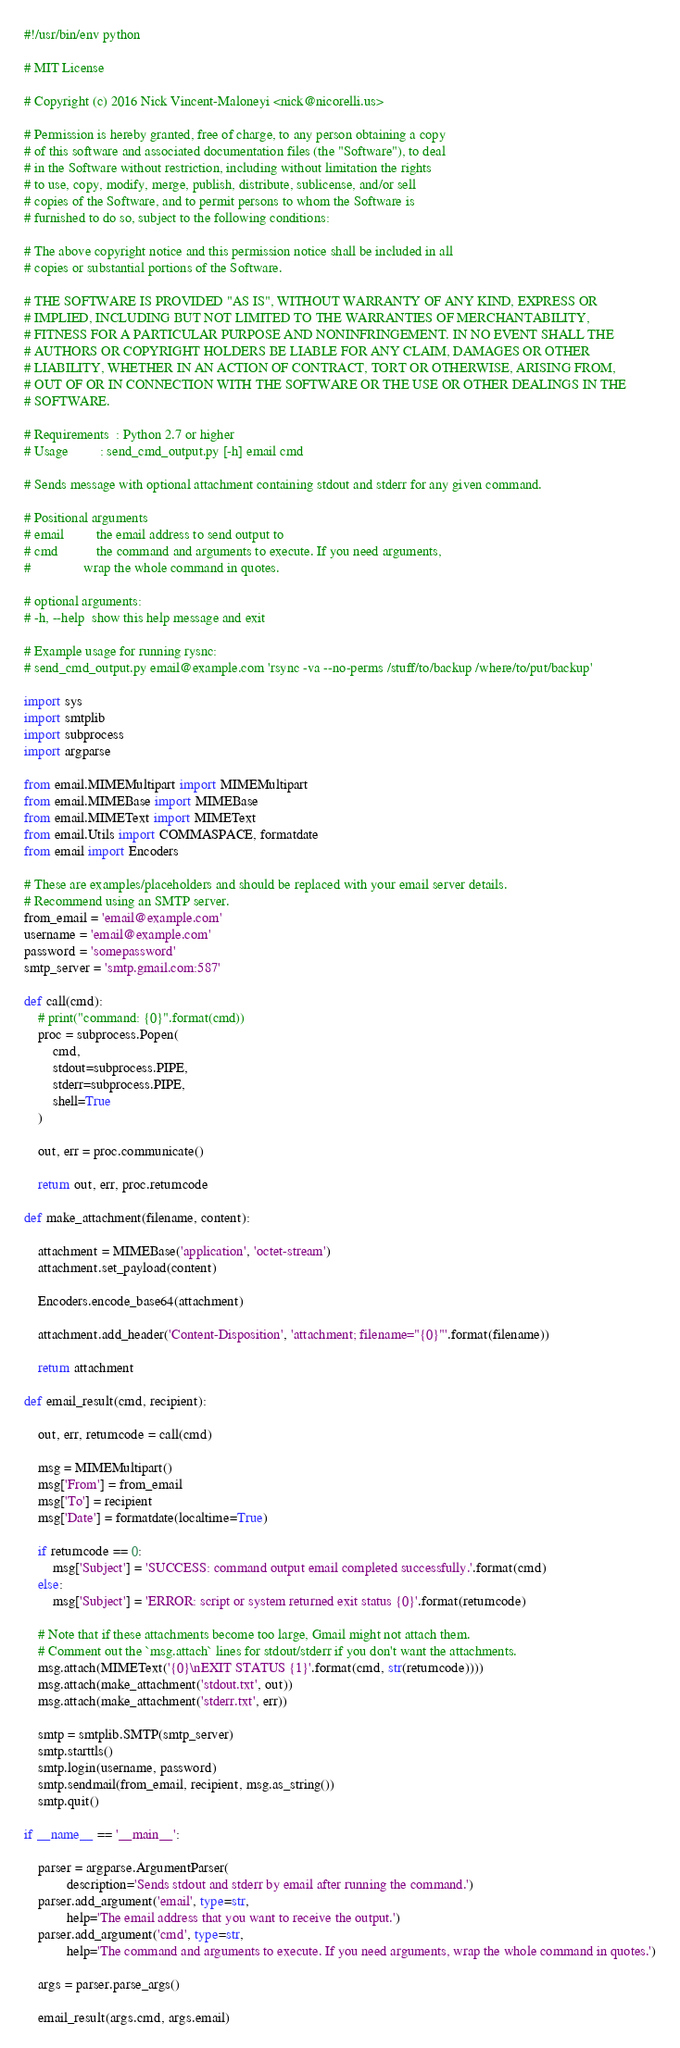<code> <loc_0><loc_0><loc_500><loc_500><_Python_>#!/usr/bin/env python

# MIT License

# Copyright (c) 2016 Nick Vincent-Maloneyi <nick@nicorelli.us>

# Permission is hereby granted, free of charge, to any person obtaining a copy
# of this software and associated documentation files (the "Software"), to deal
# in the Software without restriction, including without limitation the rights
# to use, copy, modify, merge, publish, distribute, sublicense, and/or sell
# copies of the Software, and to permit persons to whom the Software is
# furnished to do so, subject to the following conditions:
 
# The above copyright notice and this permission notice shall be included in all
# copies or substantial portions of the Software.
 
# THE SOFTWARE IS PROVIDED "AS IS", WITHOUT WARRANTY OF ANY KIND, EXPRESS OR
# IMPLIED, INCLUDING BUT NOT LIMITED TO THE WARRANTIES OF MERCHANTABILITY,
# FITNESS FOR A PARTICULAR PURPOSE AND NONINFRINGEMENT. IN NO EVENT SHALL THE
# AUTHORS OR COPYRIGHT HOLDERS BE LIABLE FOR ANY CLAIM, DAMAGES OR OTHER
# LIABILITY, WHETHER IN AN ACTION OF CONTRACT, TORT OR OTHERWISE, ARISING FROM,
# OUT OF OR IN CONNECTION WITH THE SOFTWARE OR THE USE OR OTHER DEALINGS IN THE
# SOFTWARE.
 
# Requirements  : Python 2.7 or higher  
# Usage         : send_cmd_output.py [-h] email cmd

# Sends message with optional attachment containing stdout and stderr for any given command.

# Positional arguments
# email         the email address to send output to
# cmd           the command and arguments to execute. If you need arguments,
#               wrap the whole command in quotes.

# optional arguments:
# -h, --help  show this help message and exit

# Example usage for running rysnc:
# send_cmd_output.py email@example.com 'rsync -va --no-perms /stuff/to/backup /where/to/put/backup'            

import sys
import smtplib
import subprocess
import argparse

from email.MIMEMultipart import MIMEMultipart
from email.MIMEBase import MIMEBase
from email.MIMEText import MIMEText
from email.Utils import COMMASPACE, formatdate
from email import Encoders

# These are examples/placeholders and should be replaced with your email server details.
# Recommend using an SMTP server.
from_email = 'email@example.com'
username = 'email@example.com'
password = 'somepassword'
smtp_server = 'smtp.gmail.com:587'

def call(cmd):
    # print("command: {0}".format(cmd))
    proc = subprocess.Popen(
        cmd,
        stdout=subprocess.PIPE, 
        stderr=subprocess.PIPE, 
        shell=True
    )
    
    out, err = proc.communicate()
    
    return out, err, proc.returncode

def make_attachment(filename, content):
    
    attachment = MIMEBase('application', 'octet-stream')
    attachment.set_payload(content)
    
    Encoders.encode_base64(attachment)
    
    attachment.add_header('Content-Disposition', 'attachment; filename="{0}"'.format(filename))
    
    return attachment

def email_result(cmd, recipient):
    
    out, err, returncode = call(cmd)
    
    msg = MIMEMultipart()
    msg['From'] = from_email
    msg['To'] = recipient
    msg['Date'] = formatdate(localtime=True)
    
    if returncode == 0:
        msg['Subject'] = 'SUCCESS: command output email completed successfully.'.format(cmd)
    else:
        msg['Subject'] = 'ERROR: script or system returned exit status {0}'.format(returncode) 
 
    # Note that if these attachments become too large, Gmail might not attach them.
    # Comment out the `msg.attach` lines for stdout/stderr if you don't want the attachments.
    msg.attach(MIMEText('{0}\nEXIT STATUS {1}'.format(cmd, str(returncode))))
    msg.attach(make_attachment('stdout.txt', out))
    msg.attach(make_attachment('stderr.txt', err))
    
    smtp = smtplib.SMTP(smtp_server)
    smtp.starttls()
    smtp.login(username, password)
    smtp.sendmail(from_email, recipient, msg.as_string())
    smtp.quit()

if __name__ == '__main__':
    
    parser = argparse.ArgumentParser(
            description='Sends stdout and stderr by email after running the command.')
    parser.add_argument('email', type=str,
            help='The email address that you want to receive the output.')
    parser.add_argument('cmd', type=str,
            help='The command and arguments to execute. If you need arguments, wrap the whole command in quotes.')
    
    args = parser.parse_args()
    
    email_result(args.cmd, args.email)
</code> 